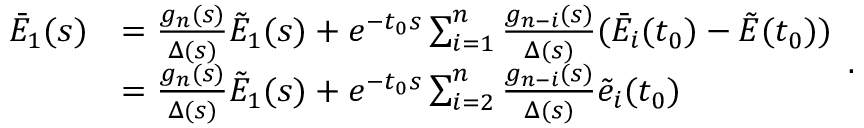Convert formula to latex. <formula><loc_0><loc_0><loc_500><loc_500>\begin{array} { r l } { { \bar { E } _ { 1 } } ( s ) } & { = \frac { { { g _ { n } } ( s ) } } { \Delta ( s ) } { { \tilde { E } } _ { 1 } } ( s ) + { e ^ { - { t _ { 0 } } s } } \sum _ { i = 1 } ^ { n } { \frac { { { g _ { n - i } } ( s ) } } { \Delta ( s ) } ( { { \bar { E } } _ { i } } ( { t _ { 0 } } ) - \tilde { E } ( { t _ { 0 } } ) ) } } \\ & { = \frac { { { g _ { n } } ( s ) } } { \Delta ( s ) } { { \tilde { E } } _ { 1 } } ( s ) + { e ^ { - { t _ { 0 } } s } } \sum _ { i = 2 } ^ { n } { \frac { { { g _ { n - i } } ( s ) } } { \Delta ( s ) } \tilde { e } _ { i } ( { t _ { 0 } } ) } } \end{array} .</formula> 